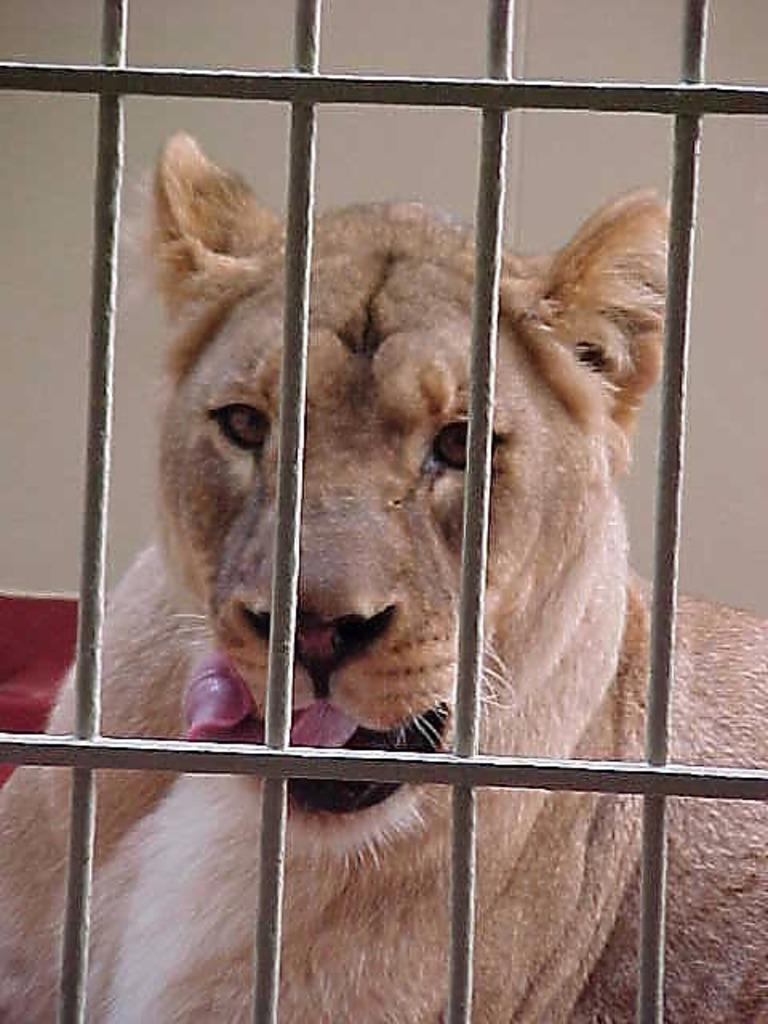What is the main object in the image? There is a grill in the image. What can be seen through the grill? An animal is visible through the grill. What is in the background of the image? There is a wall in the background of the image. What type of locket is hanging from the grill in the image? There is no locket present in the image; it features a grill and an animal visible through it. 